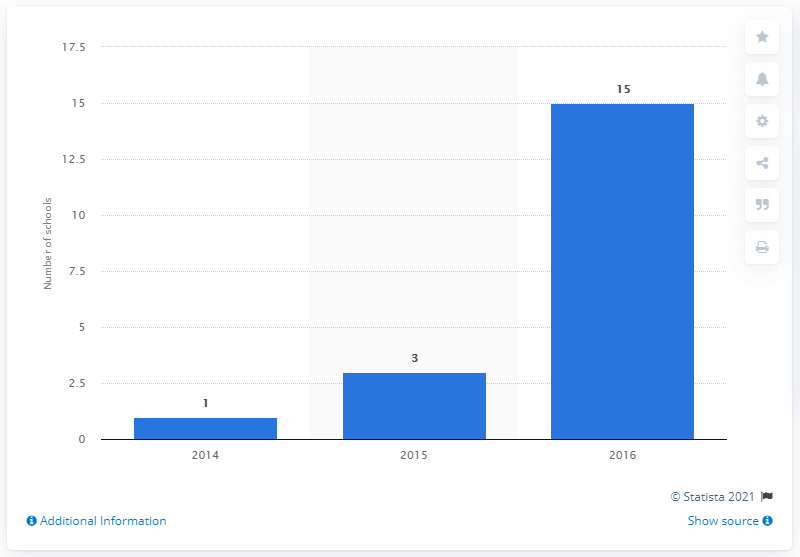Mention a couple of crucial points in this snapshot. In 2016, it was reported that 15 schools offered eSports scholarships. 